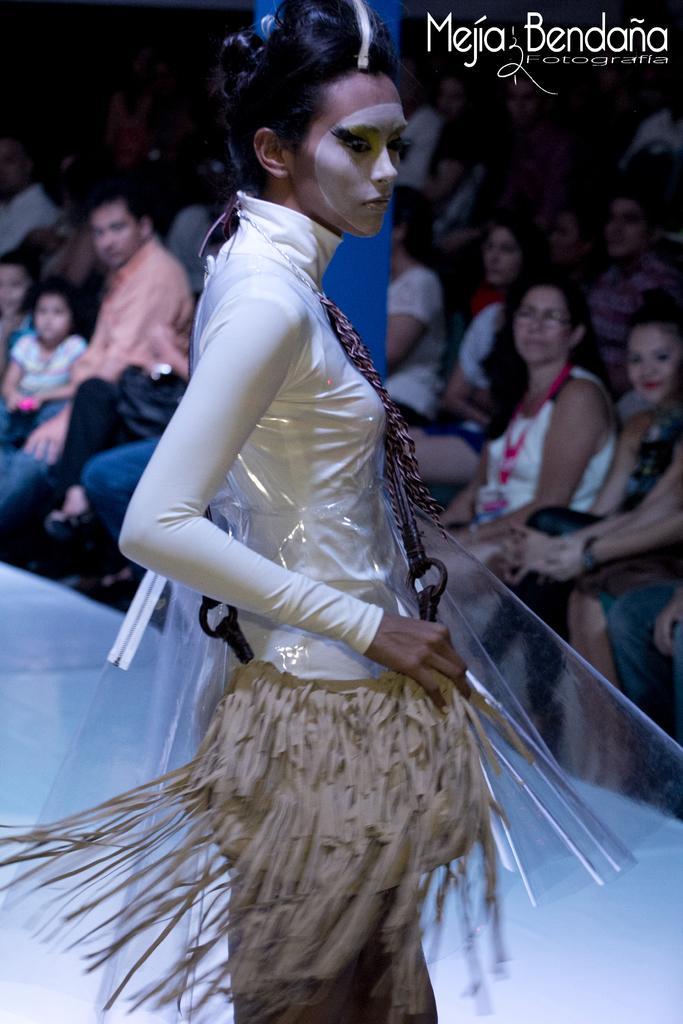How would you summarize this image in a sentence or two? In this picture we can observe a woman wearing a cream color costume on the ramp. There are some people sitting in the chairs. There are men and women. We can observe a white color words on the right side of this image. 